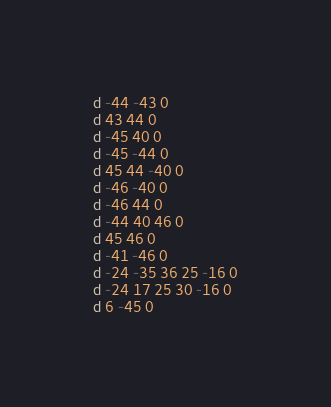Convert code to text. <code><loc_0><loc_0><loc_500><loc_500><_Pascal_>d -44 -43 0
d 43 44 0
d -45 40 0
d -45 -44 0
d 45 44 -40 0
d -46 -40 0
d -46 44 0
d -44 40 46 0
d 45 46 0
d -41 -46 0
d -24 -35 36 25 -16 0
d -24 17 25 30 -16 0
d 6 -45 0</code> 